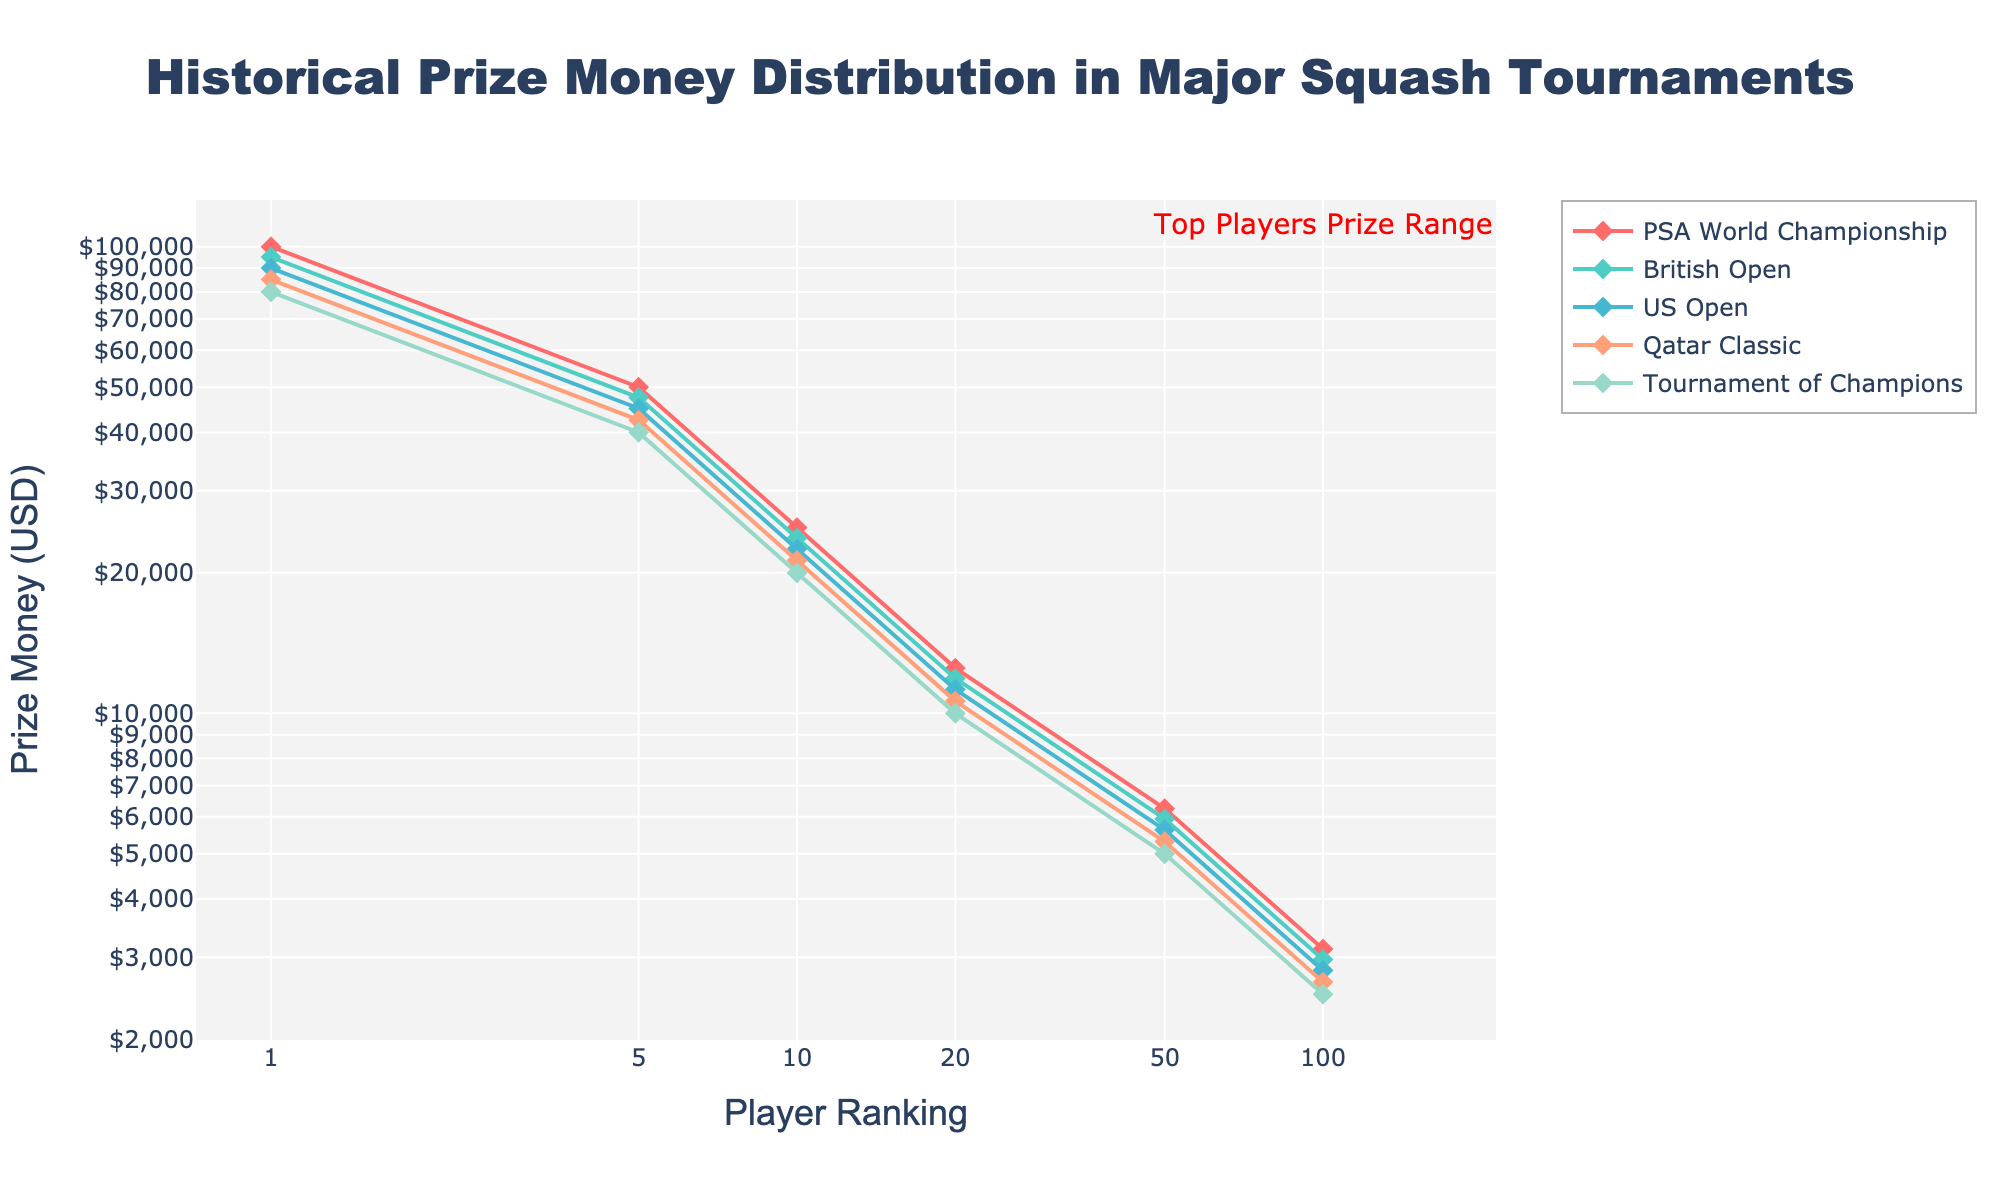What is the maximum prize money awarded in the PSA World Championship? By looking at the PSA World Championship line, the maximum prize money corresponds to the highest ranked position (Rank 1) on the x-axis.
Answer: 100,000 USD How does the prize money drop from Rank 1 to Rank 5 in the Tournament of Champions? Observe the Tournament of Champions line. The prize money at Rank 1 is 80,000 USD, and at Rank 5 it is 40,000 USD. The drop is calculated as the difference: 80,000 - 40,000 = 40,000 USD.
Answer: 40,000 USD Which tournament awards the highest prize money for a player ranked 10th? Compare the prize money at Rank 10 for all tournament lines. The highest value is 25,000 USD for the PSA World Championship.
Answer: PSA World Championship If a player ranked 20th were to participate in all listed tournaments, what would be their total earnings? Sum the prize money for a 20th-ranked player across all tournaments: 12,500 + 11,875 + 11,250 + 10,625 + 10,000 = 56,250 USD.
Answer: 56,250 USD Which tournament shows the steepest decline in prize money from Rank 1 to Rank 100? Calculate the decline for each tournament and compare. For the PSA World Championship, it's 100,000 - 3,125 = 96,875 USD; for the British Open, 95,000 - 2,969 = 92,031 USD; for the US Open, 90,000 - 2,813 = 87,187 USD; for the Qatar Classic, 85,000 - 2,656 = 82,344 USD; for the Tournament of Champions, 80,000 - 2,500 = 77,500 USD. The steepest decline is in the PSA World Championship.
Answer: PSA World Championship For Rank 50, which two tournaments have the closest prize money amounts and what is the difference? Compare the Rank 50 prize money for all tournaments: PSA World Championship (6250 USD), British Open (5938 USD), US Open (5625 USD), Qatar Classic (5313 USD), Tournament of Champions (5000 USD). The closest amounts are US Open (5625 USD) and Qatar Classic (5313 USD). The difference is 5625 - 5313 = 312 USD.
Answer: US Open and Qatar Classic, 312 USD By what factor does the prize money decrease from Rank 1 to Rank 50 in the British Open? The prize money for Rank 1 is 95,000 USD, and for Rank 50 it's 5938 USD. The factor is calculated as 95,000 / 5938 ≈ 16.
Answer: Approx. 16 What is the range of prize money for players ranked in the top 20 in the Qatar Classic? The prize money for Rank 1 in Qatar Classic is 85,000 USD, and for Rank 20 it is 10,625 USD. The range is 85,000 - 10,625 = 74,375 USD.
Answer: 74,375 USD Highlighting the top players, defined as Rank 1 to Rank 20 in this chart, which tournament provides the least prize money for these top-ranked players on average? Calculate the average prize for top 20 ranked players in each tournament. Sum the prize money from Rank 1 to Rank 20 for each tournament and divide by 20. Without exact figures for each rank from 2-19, an estimation shows that the Tournament of Champions starts with the lowest prize money at Rank 1 (80,000 USD) and further decreases at a similar pace, suggesting it might have the lowest average prize.
Answer: Tournament of Champions How does the appearance of the PSA World Championship line differ from the other tournament lines? The PSA World Championship line is higher than other tournament lines, indicating higher prize money at all rankings. Additionally, it has the largest difference between Rank 1 and Rank 100 prize money.
Answer: Higher and steeper drop 